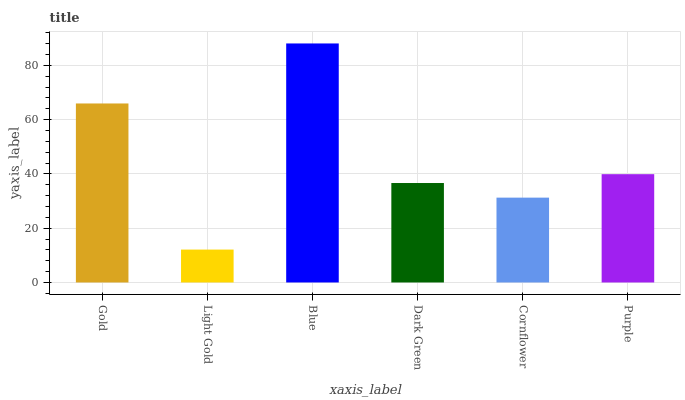Is Light Gold the minimum?
Answer yes or no. Yes. Is Blue the maximum?
Answer yes or no. Yes. Is Blue the minimum?
Answer yes or no. No. Is Light Gold the maximum?
Answer yes or no. No. Is Blue greater than Light Gold?
Answer yes or no. Yes. Is Light Gold less than Blue?
Answer yes or no. Yes. Is Light Gold greater than Blue?
Answer yes or no. No. Is Blue less than Light Gold?
Answer yes or no. No. Is Purple the high median?
Answer yes or no. Yes. Is Dark Green the low median?
Answer yes or no. Yes. Is Blue the high median?
Answer yes or no. No. Is Gold the low median?
Answer yes or no. No. 